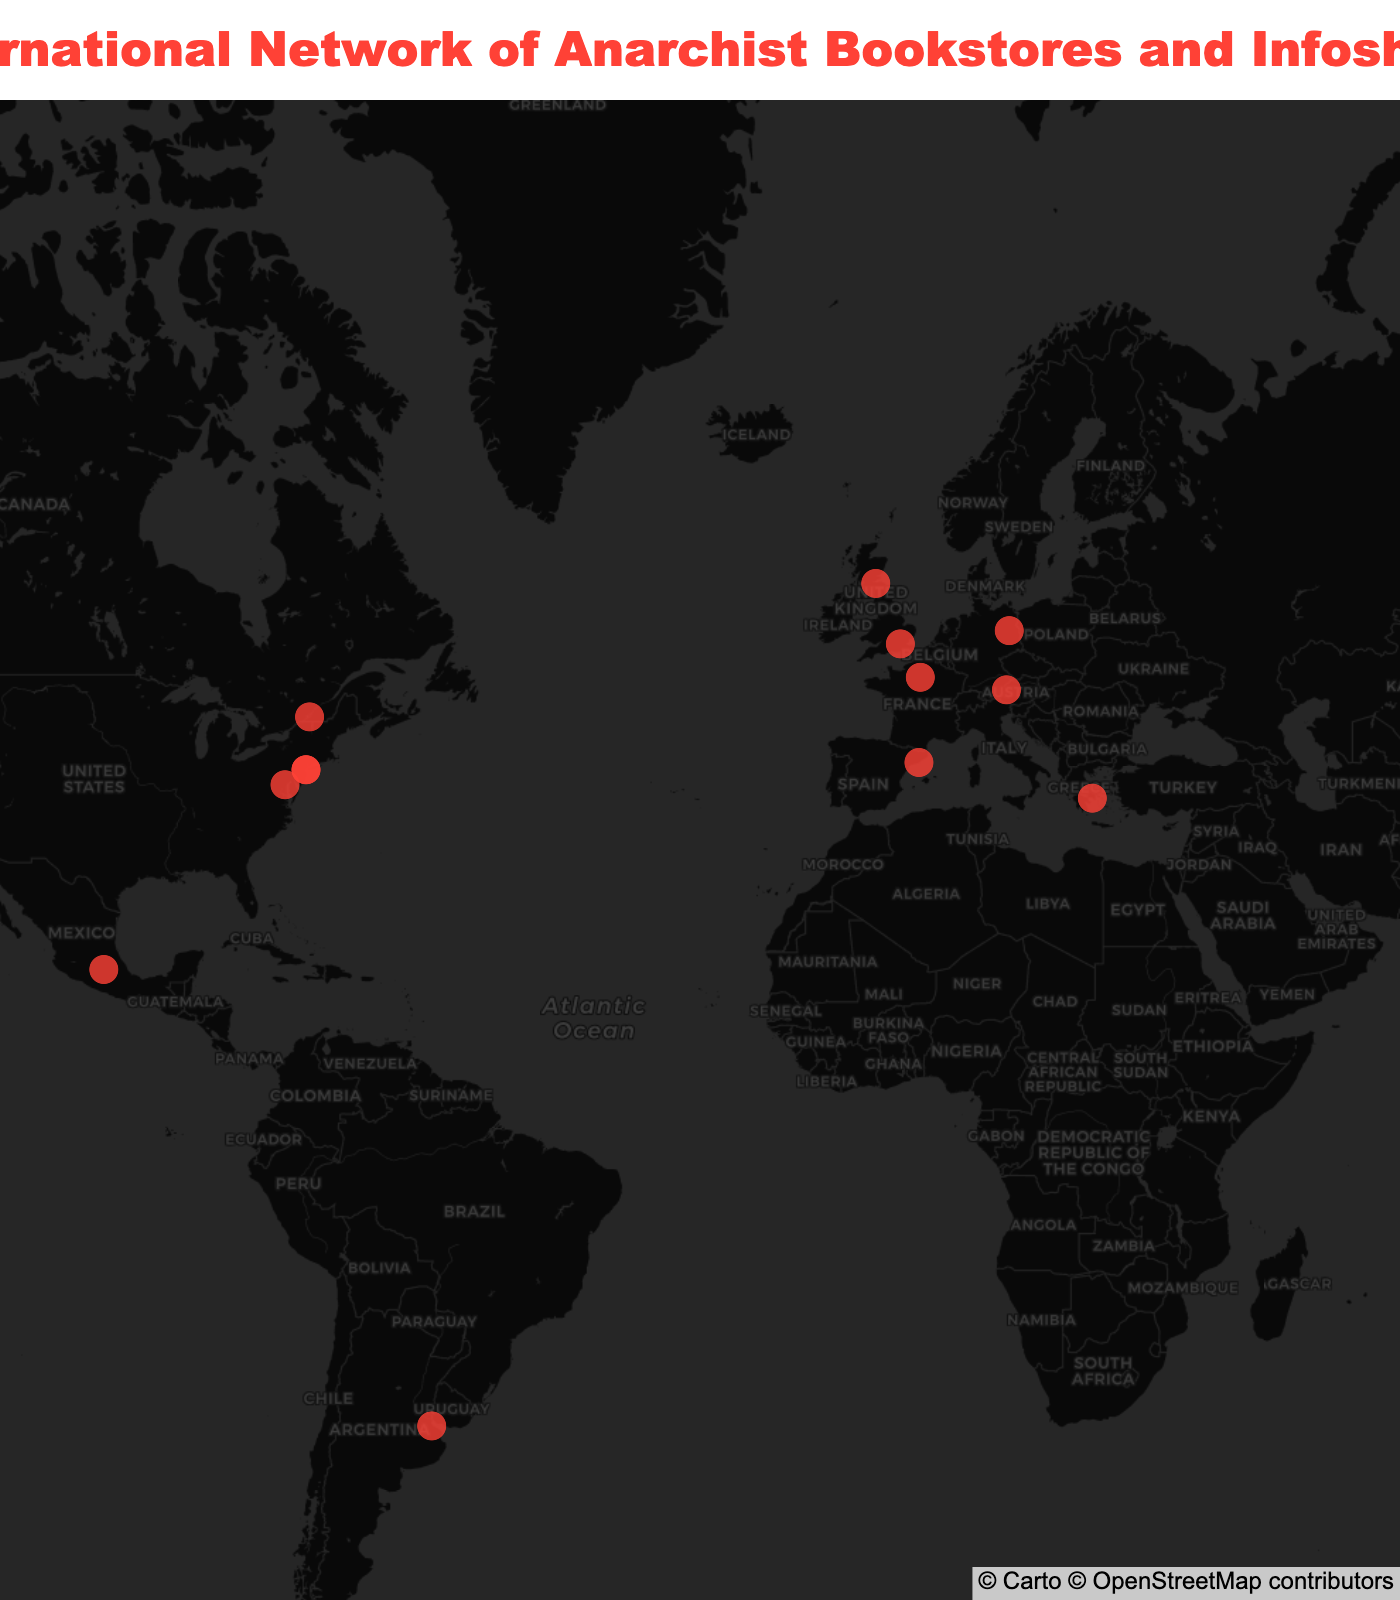What's the title of the map? The title is displayed at the top of the map in bold text.
Answer: International Network of Anarchist Bookstores and Infoshops How many anarchist bookstores and infoshops are shown in the map? Count the number of distinct markers on the map.
Answer: 15 Which city has multiple anarchist bookstores and infoshops featured? Observe the cities listed under the markers and find the one that repeats.
Answer: New York City What are the names of the two anarchist bookstores in New York City? Hover over the two markers in New York City to get the names.
Answer: ABC No Rio and Bluestockings Bookstore Which anarchist bookstore is located furthest west? Find the marker with the highest negative longitude value, which signifies the furthest west location.
Answer: Bound Together Books in San Francisco What is the closest anarchist bookstore to the equator? Identify the marker with the latitude closest to 0.
Answer: Libros Libertarios in Buenos Aires Compare the number of anarchist bookstores in Europe to those in North America. Which has more? Count the markers in Europe and then count those in North America. Compare the two counts.
Answer: North America has more Which countries have exactly one anarchist bookstore or infoshop? Identify the countries listed under the markers and see which ones appear only once.
Answer: Greece, Mexico, Germany, Austria, Argentina, Spain, Australia What's the approximate latitude and longitude of the anarchist bookstore in Athens? Hover over the marker in Athens to view its coordinates.
Answer: Latitude: 37.9838, Longitude: 23.7275 Which anarchist bookstore is located in the southern hemisphere? Identify the marker with a negative latitude, signifying a southern hemisphere location.
Answer: Jura Books in Sydney 